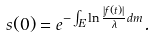<formula> <loc_0><loc_0><loc_500><loc_500>s ( 0 ) = e ^ { - \int _ { E } \ln \frac { | f ( t ) | } \lambda d m } .</formula> 